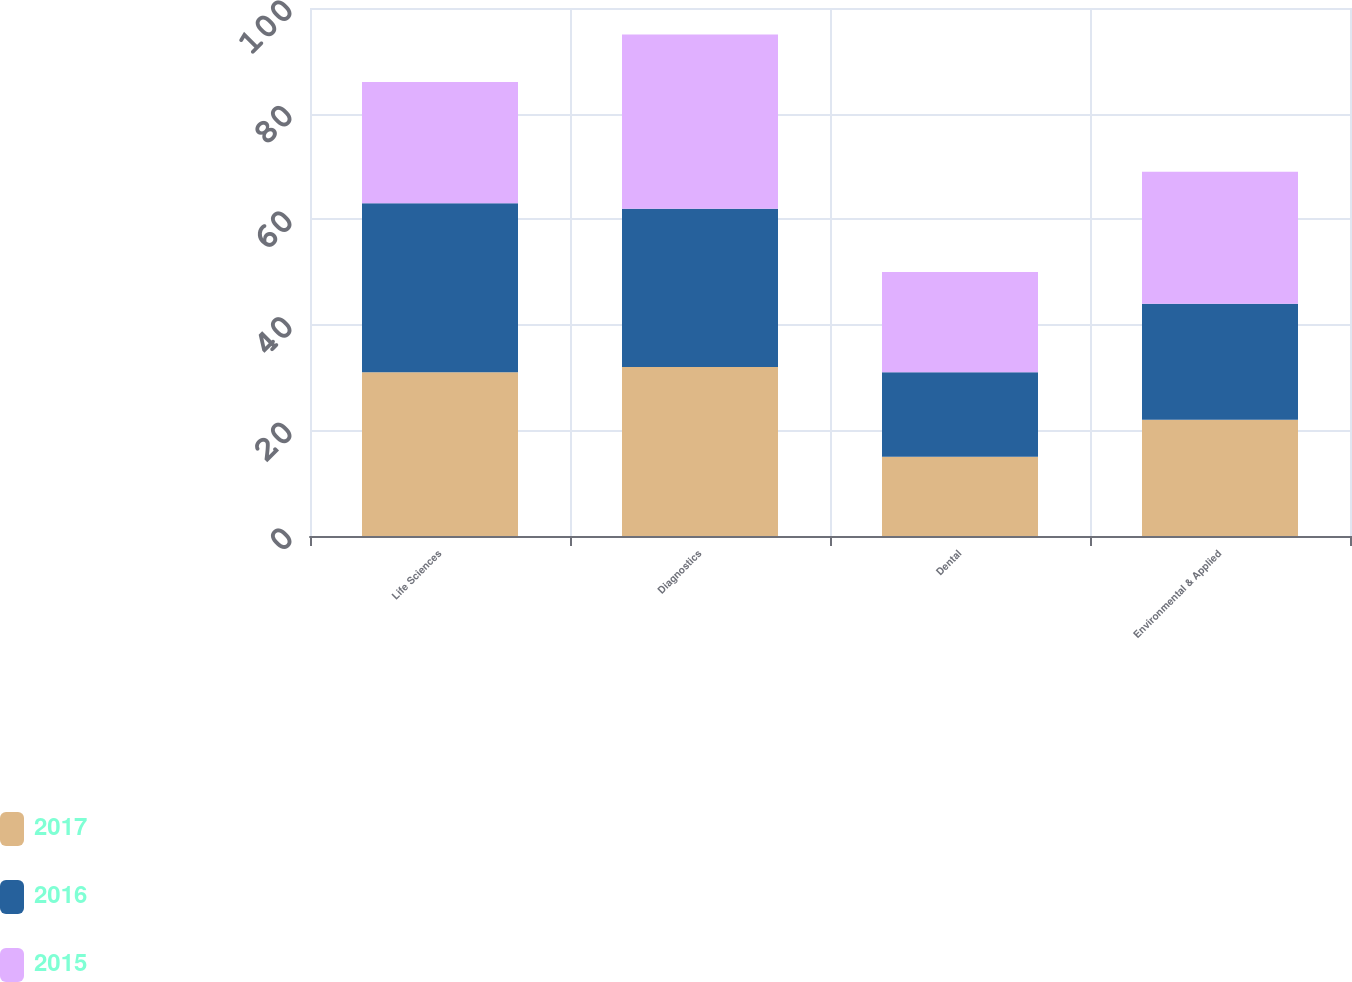Convert chart to OTSL. <chart><loc_0><loc_0><loc_500><loc_500><stacked_bar_chart><ecel><fcel>Life Sciences<fcel>Diagnostics<fcel>Dental<fcel>Environmental & Applied<nl><fcel>2017<fcel>31<fcel>32<fcel>15<fcel>22<nl><fcel>2016<fcel>32<fcel>30<fcel>16<fcel>22<nl><fcel>2015<fcel>23<fcel>33<fcel>19<fcel>25<nl></chart> 